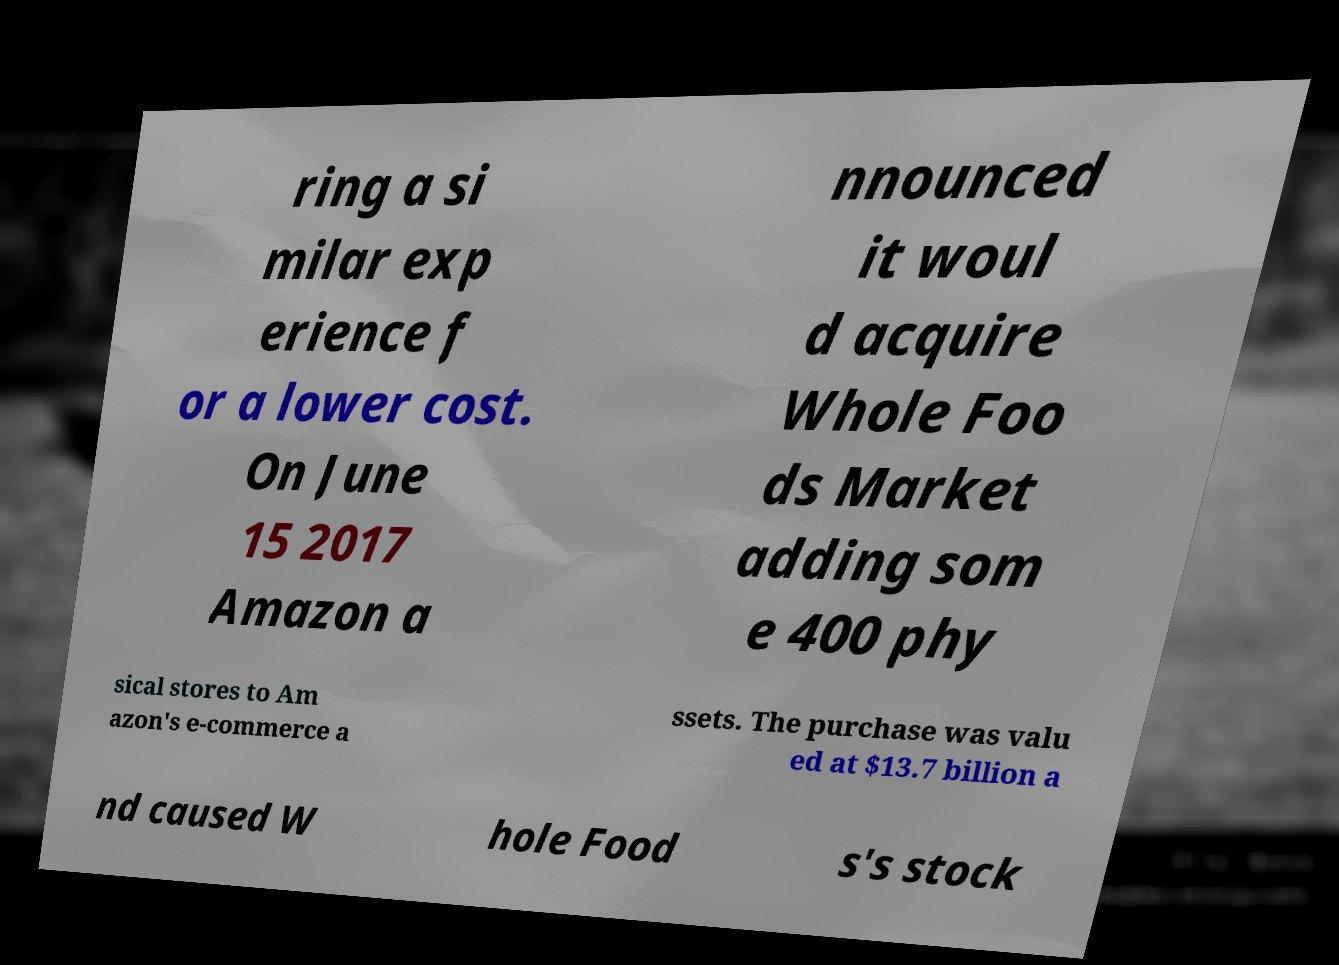Could you assist in decoding the text presented in this image and type it out clearly? ring a si milar exp erience f or a lower cost. On June 15 2017 Amazon a nnounced it woul d acquire Whole Foo ds Market adding som e 400 phy sical stores to Am azon's e-commerce a ssets. The purchase was valu ed at $13.7 billion a nd caused W hole Food s's stock 